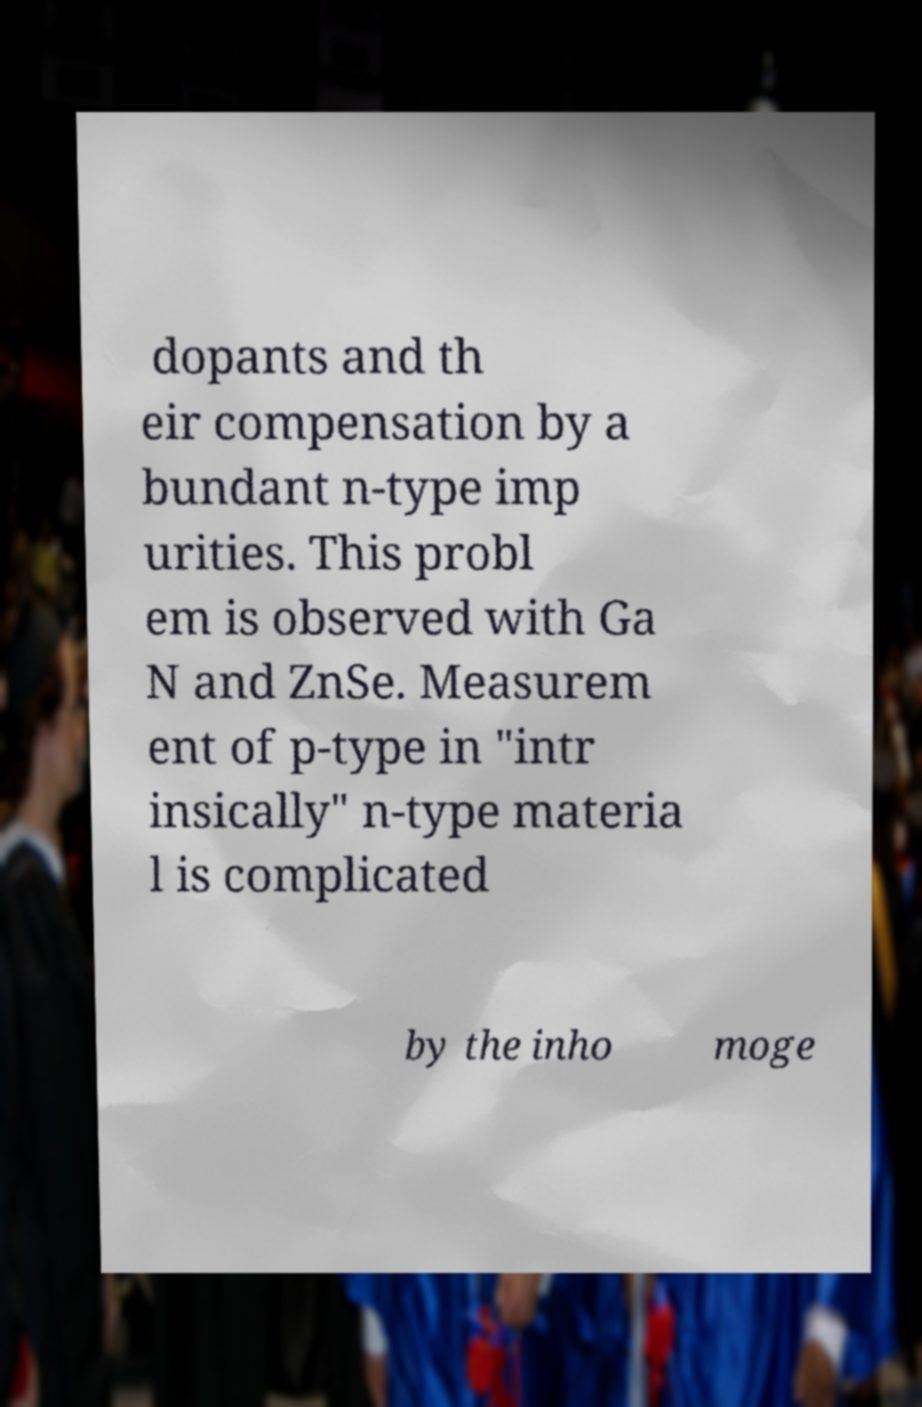Please identify and transcribe the text found in this image. dopants and th eir compensation by a bundant n-type imp urities. This probl em is observed with Ga N and ZnSe. Measurem ent of p-type in "intr insically" n-type materia l is complicated by the inho moge 